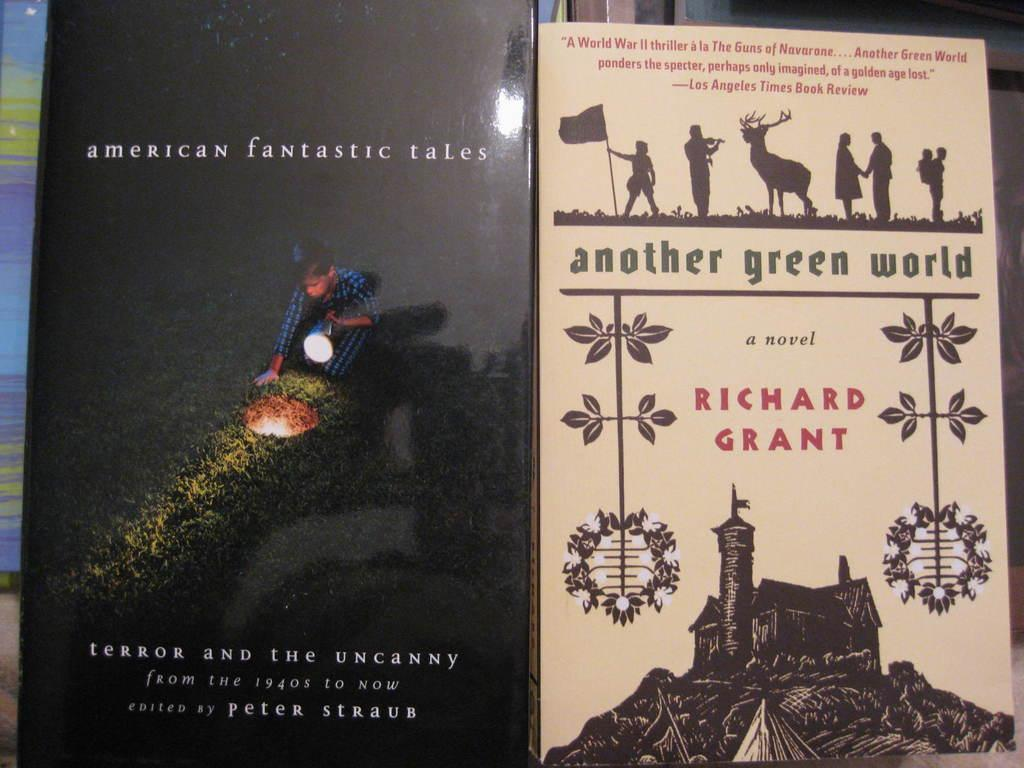<image>
Offer a succinct explanation of the picture presented. Two books next to each other one on the right titled American Fantastic Tales the other on the right Another Green World. 